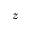<formula> <loc_0><loc_0><loc_500><loc_500>z</formula> 